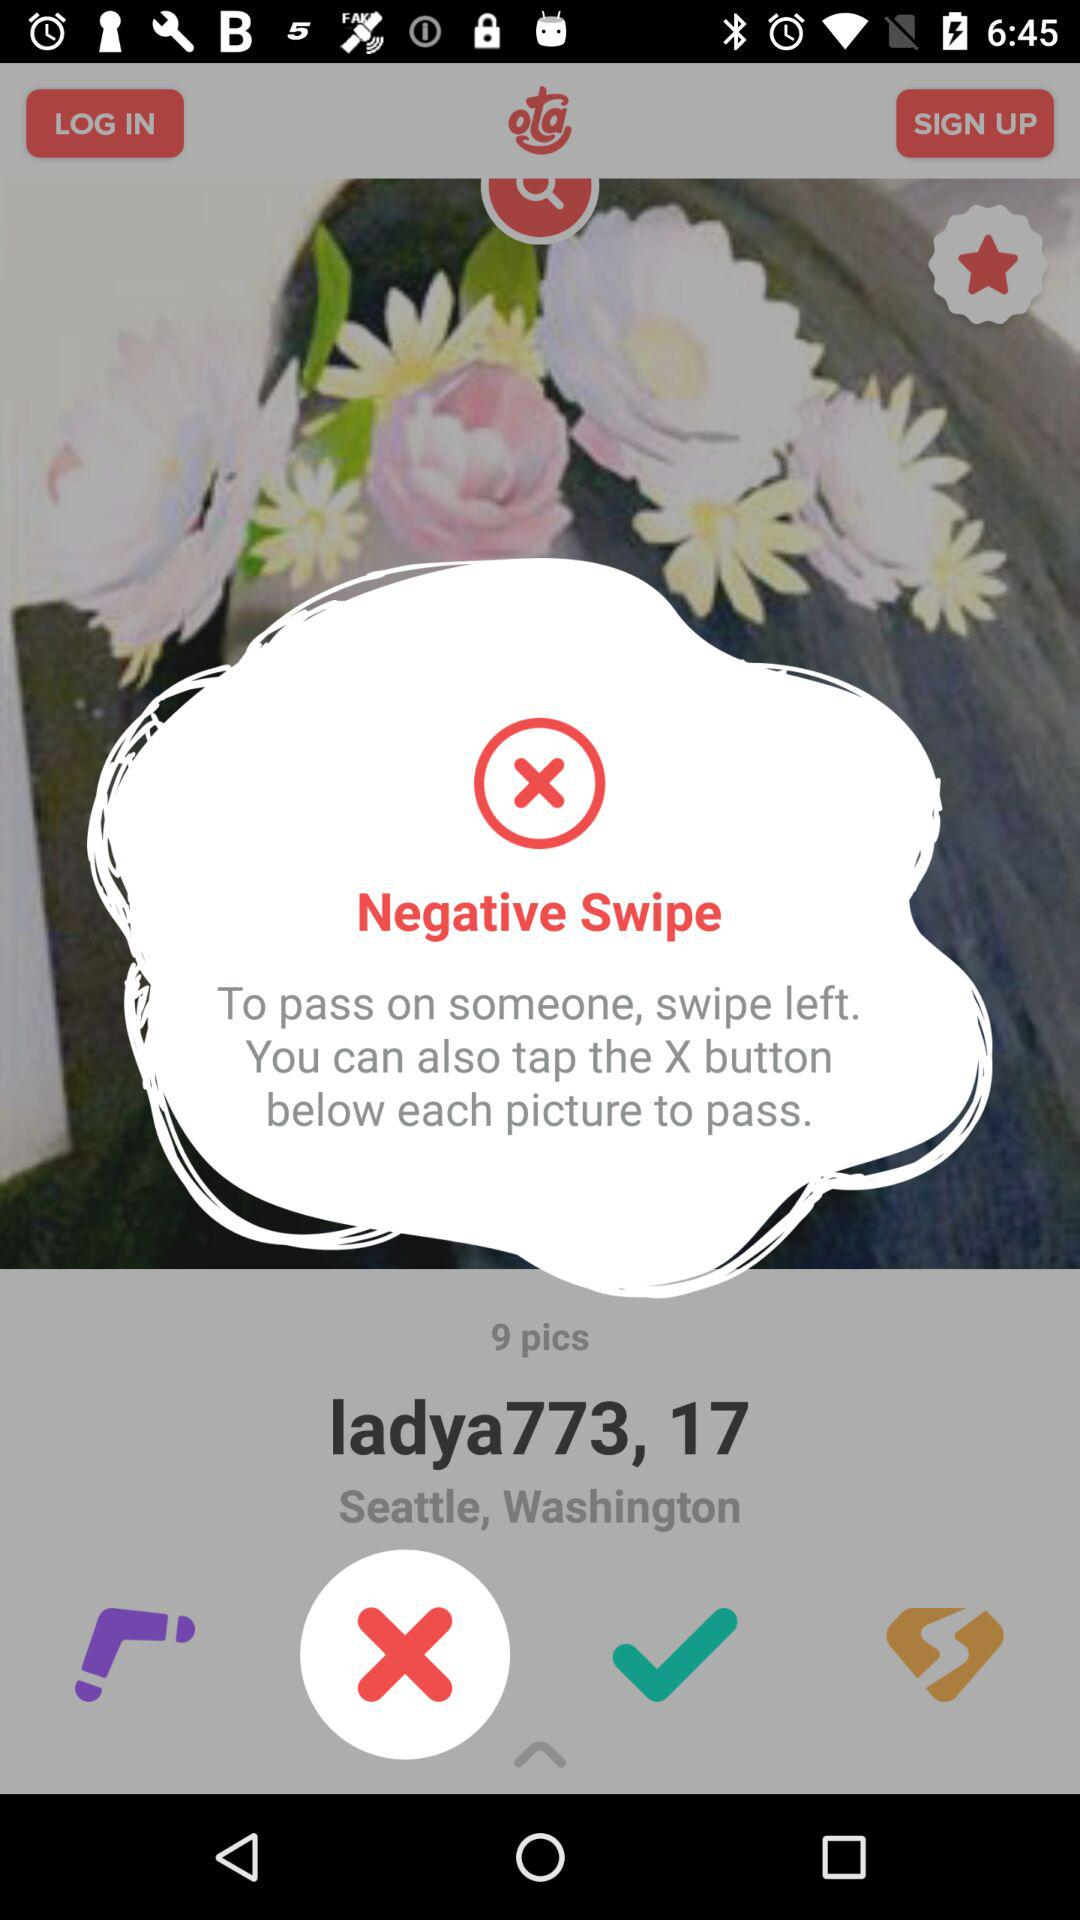What to do to pass on someone? To pass on someone, swipe left and you can also tap the X button below each picture to pass. 